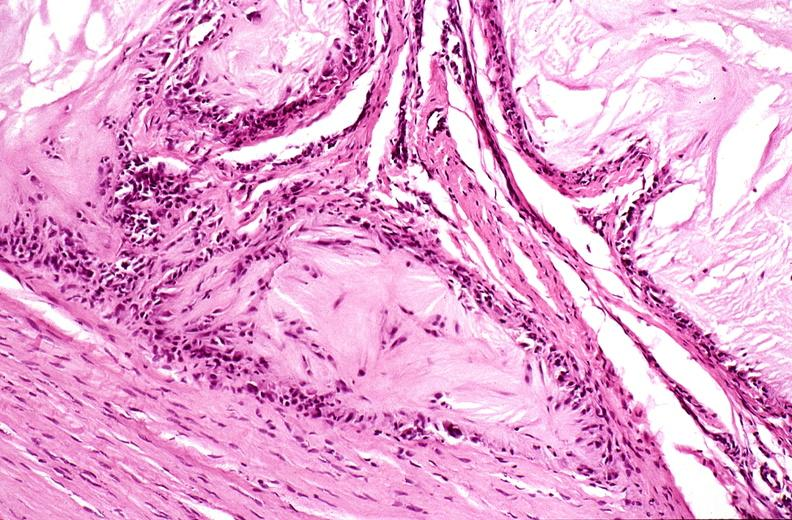s joints present?
Answer the question using a single word or phrase. Yes 